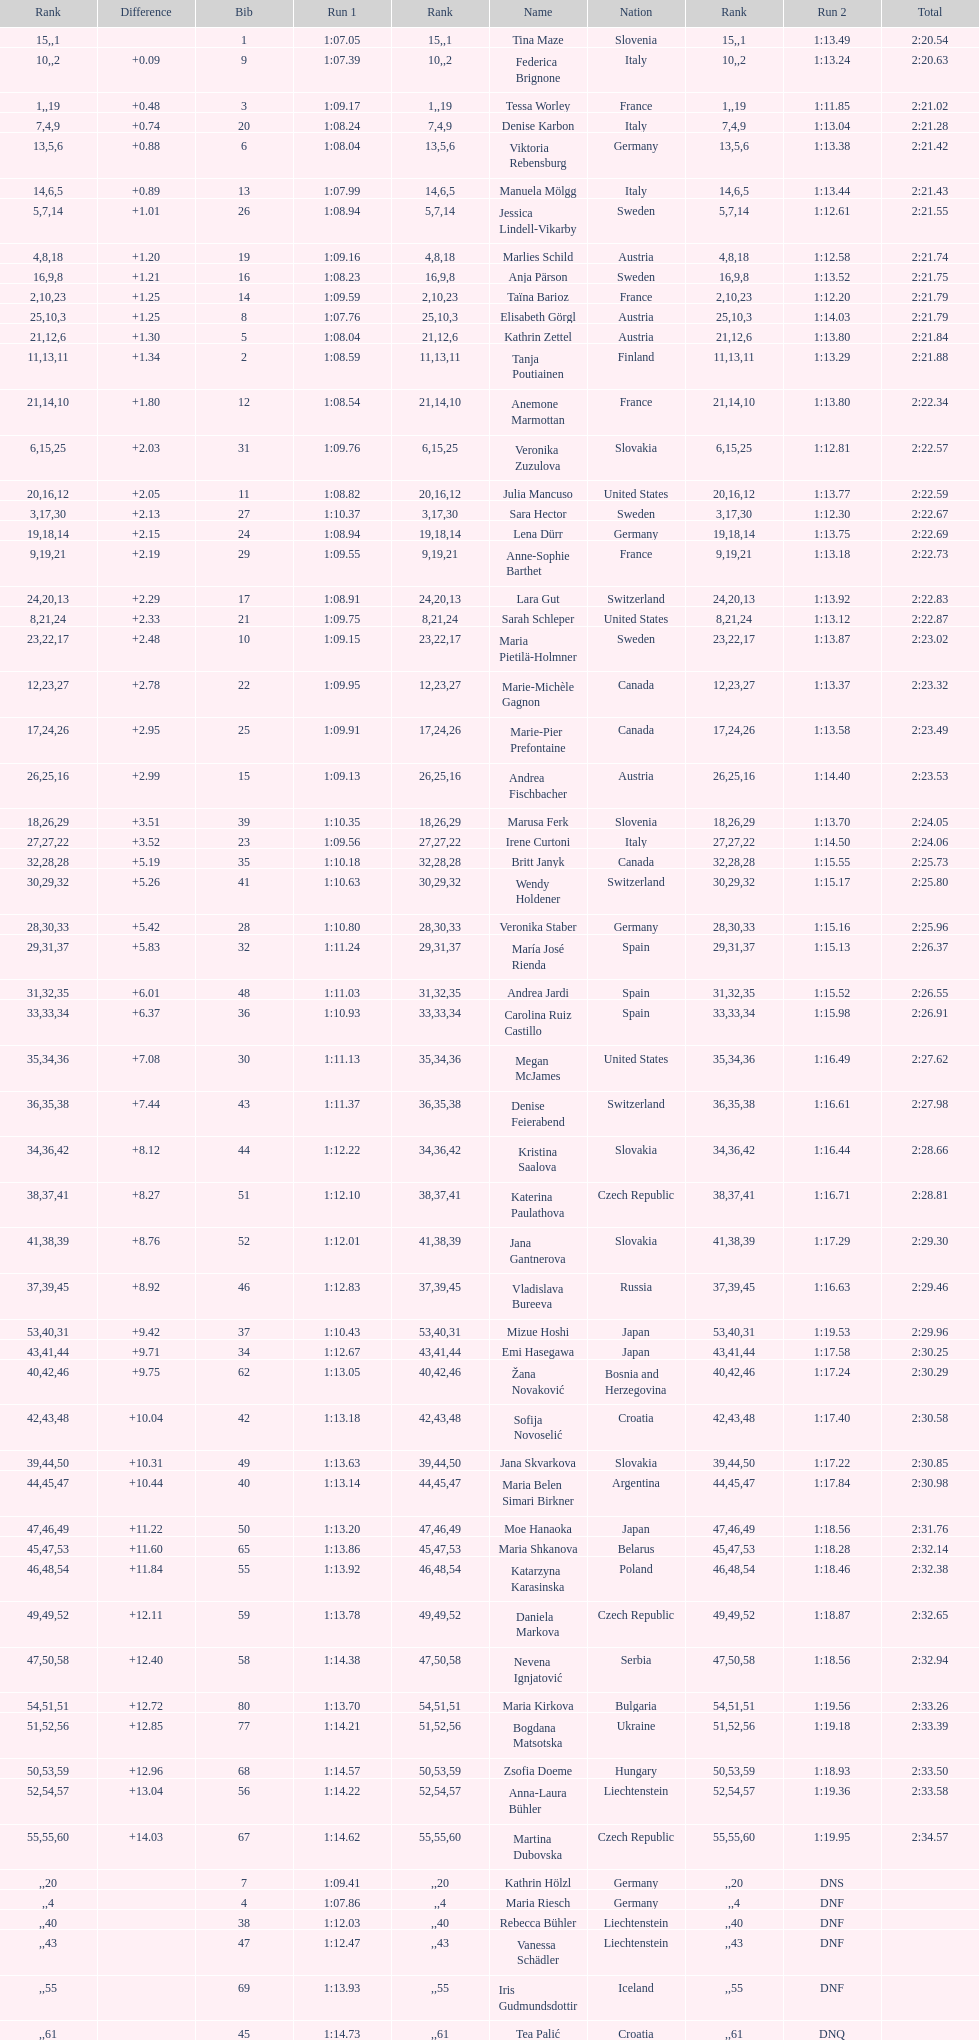What was the number of swedes in the top fifteen? 2. 